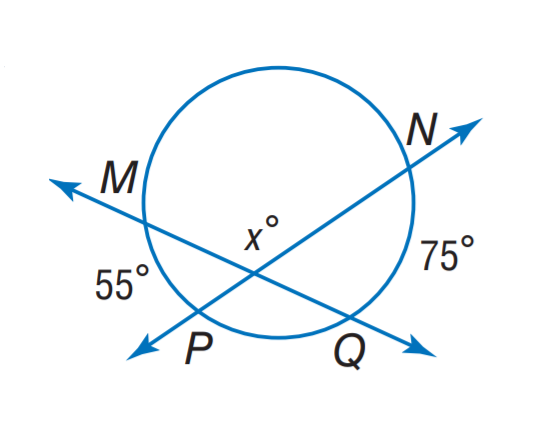Question: Find x.
Choices:
A. 95
B. 105
C. 115
D. 125
Answer with the letter. Answer: C 